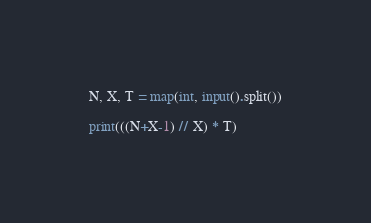Convert code to text. <code><loc_0><loc_0><loc_500><loc_500><_Python_>N, X, T = map(int, input().split())

print(((N+X-1) // X) * T)</code> 